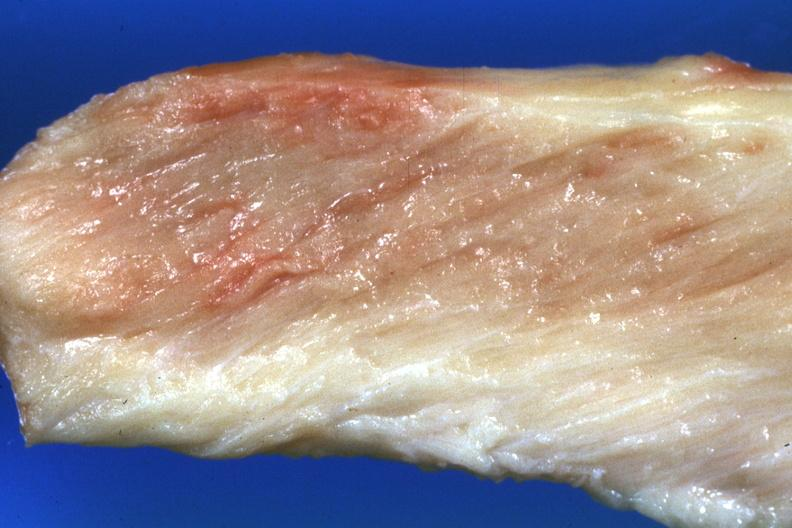what is present?
Answer the question using a single word or phrase. Soft tissue 